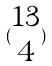<formula> <loc_0><loc_0><loc_500><loc_500>( \begin{matrix} 1 3 \\ 4 \end{matrix} )</formula> 